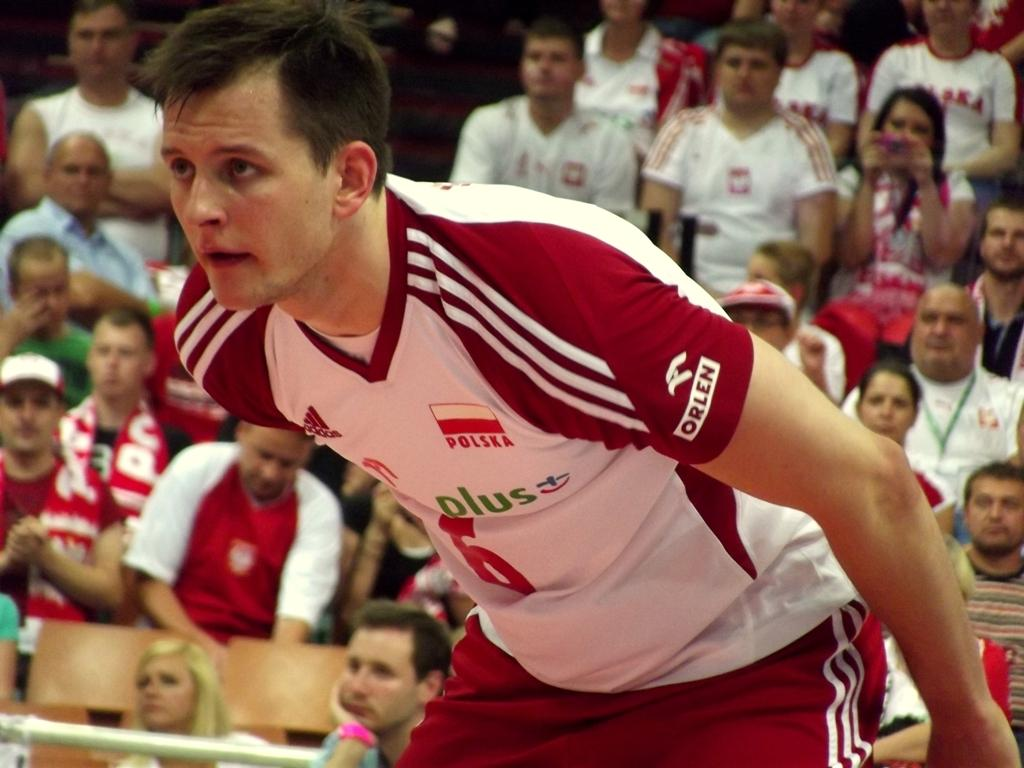What is the person in the image doing? The person in the image is in a playful position. Can you describe the people behind the person in the image? There are spectators behind the person in the image. What type of slave can be seen in the image? There is no slave present in the image. What is the moon doing in the image? The moon is not present in the image. 